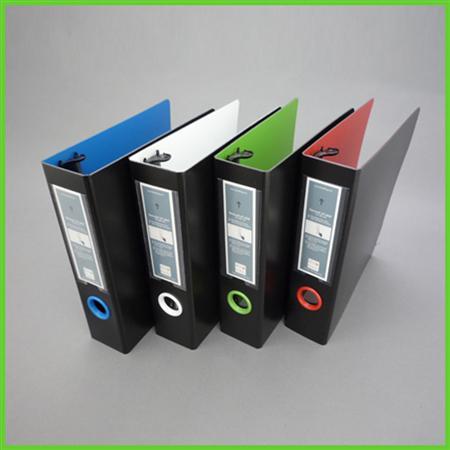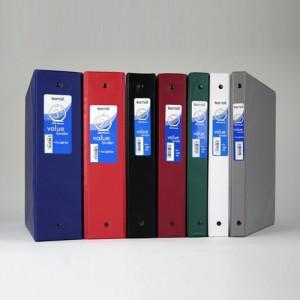The first image is the image on the left, the second image is the image on the right. Analyze the images presented: Is the assertion "There are five binders in the image pair." valid? Answer yes or no. No. The first image is the image on the left, the second image is the image on the right. Analyze the images presented: Is the assertion "One image contains a single upright binder, and the other contains a row of four binders." valid? Answer yes or no. No. 